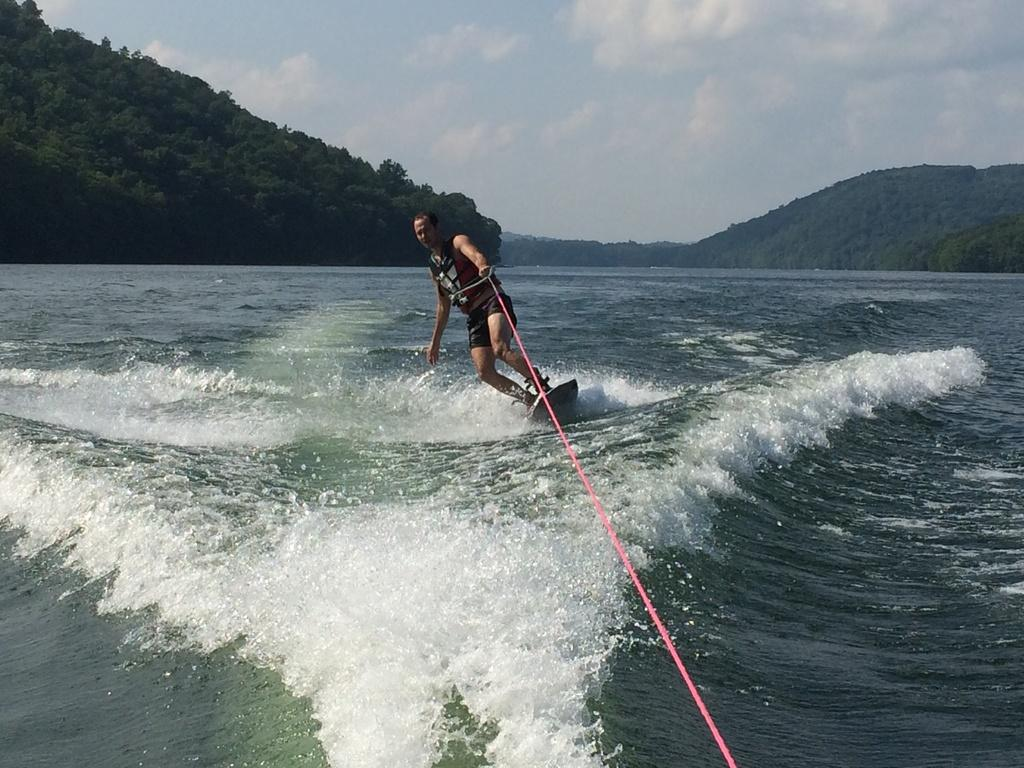What activity is the man in the image engaged in? The man is doing surfing in the sea. What can be seen on the left side of the image? There are trees on a hill on the left side of the image. What is visible at the top of the image? The sky is visible at the top of the image. How many women are visible in the image? There are no women present in the image; it features a man surfing in the sea. Can you tell me if there is a cobweb in the image? There is no cobweb present in the image. 